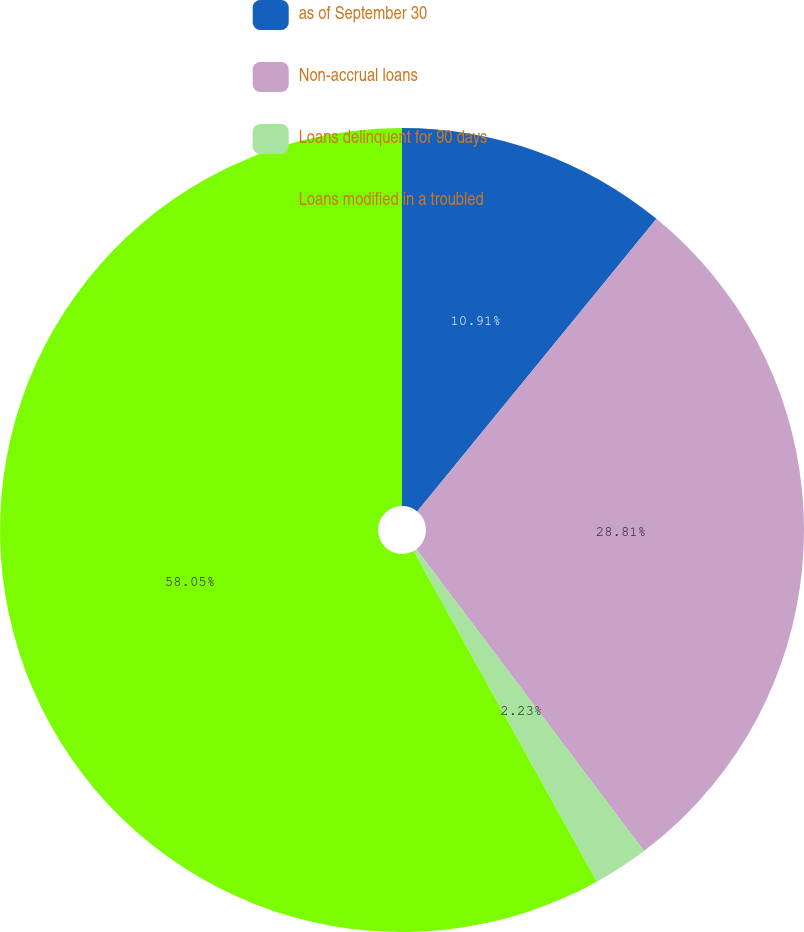<chart> <loc_0><loc_0><loc_500><loc_500><pie_chart><fcel>as of September 30<fcel>Non-accrual loans<fcel>Loans delinquent for 90 days<fcel>Loans modified in a troubled<nl><fcel>10.91%<fcel>28.81%<fcel>2.23%<fcel>58.05%<nl></chart> 